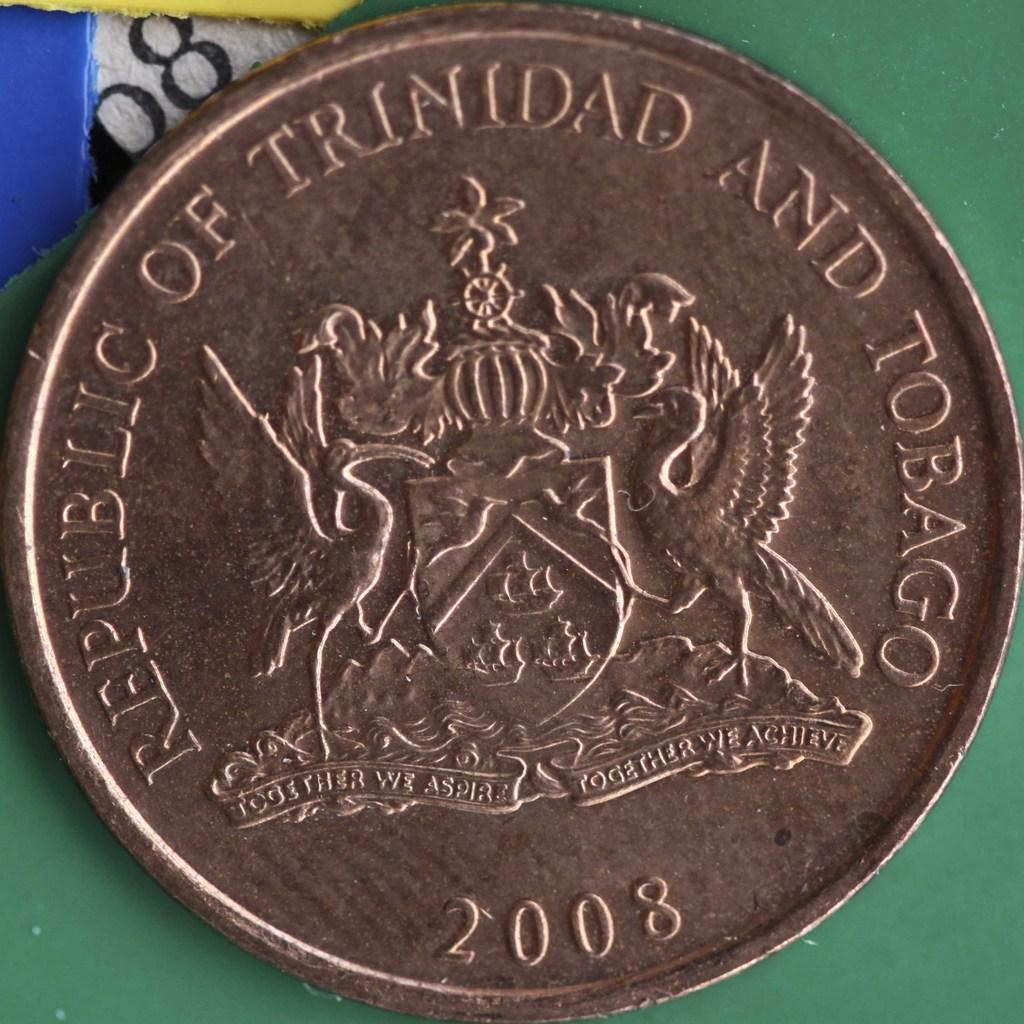<image>
Provide a brief description of the given image. Republic of Trinidad and Tobago, 2008 is etched in the face of this coin. 